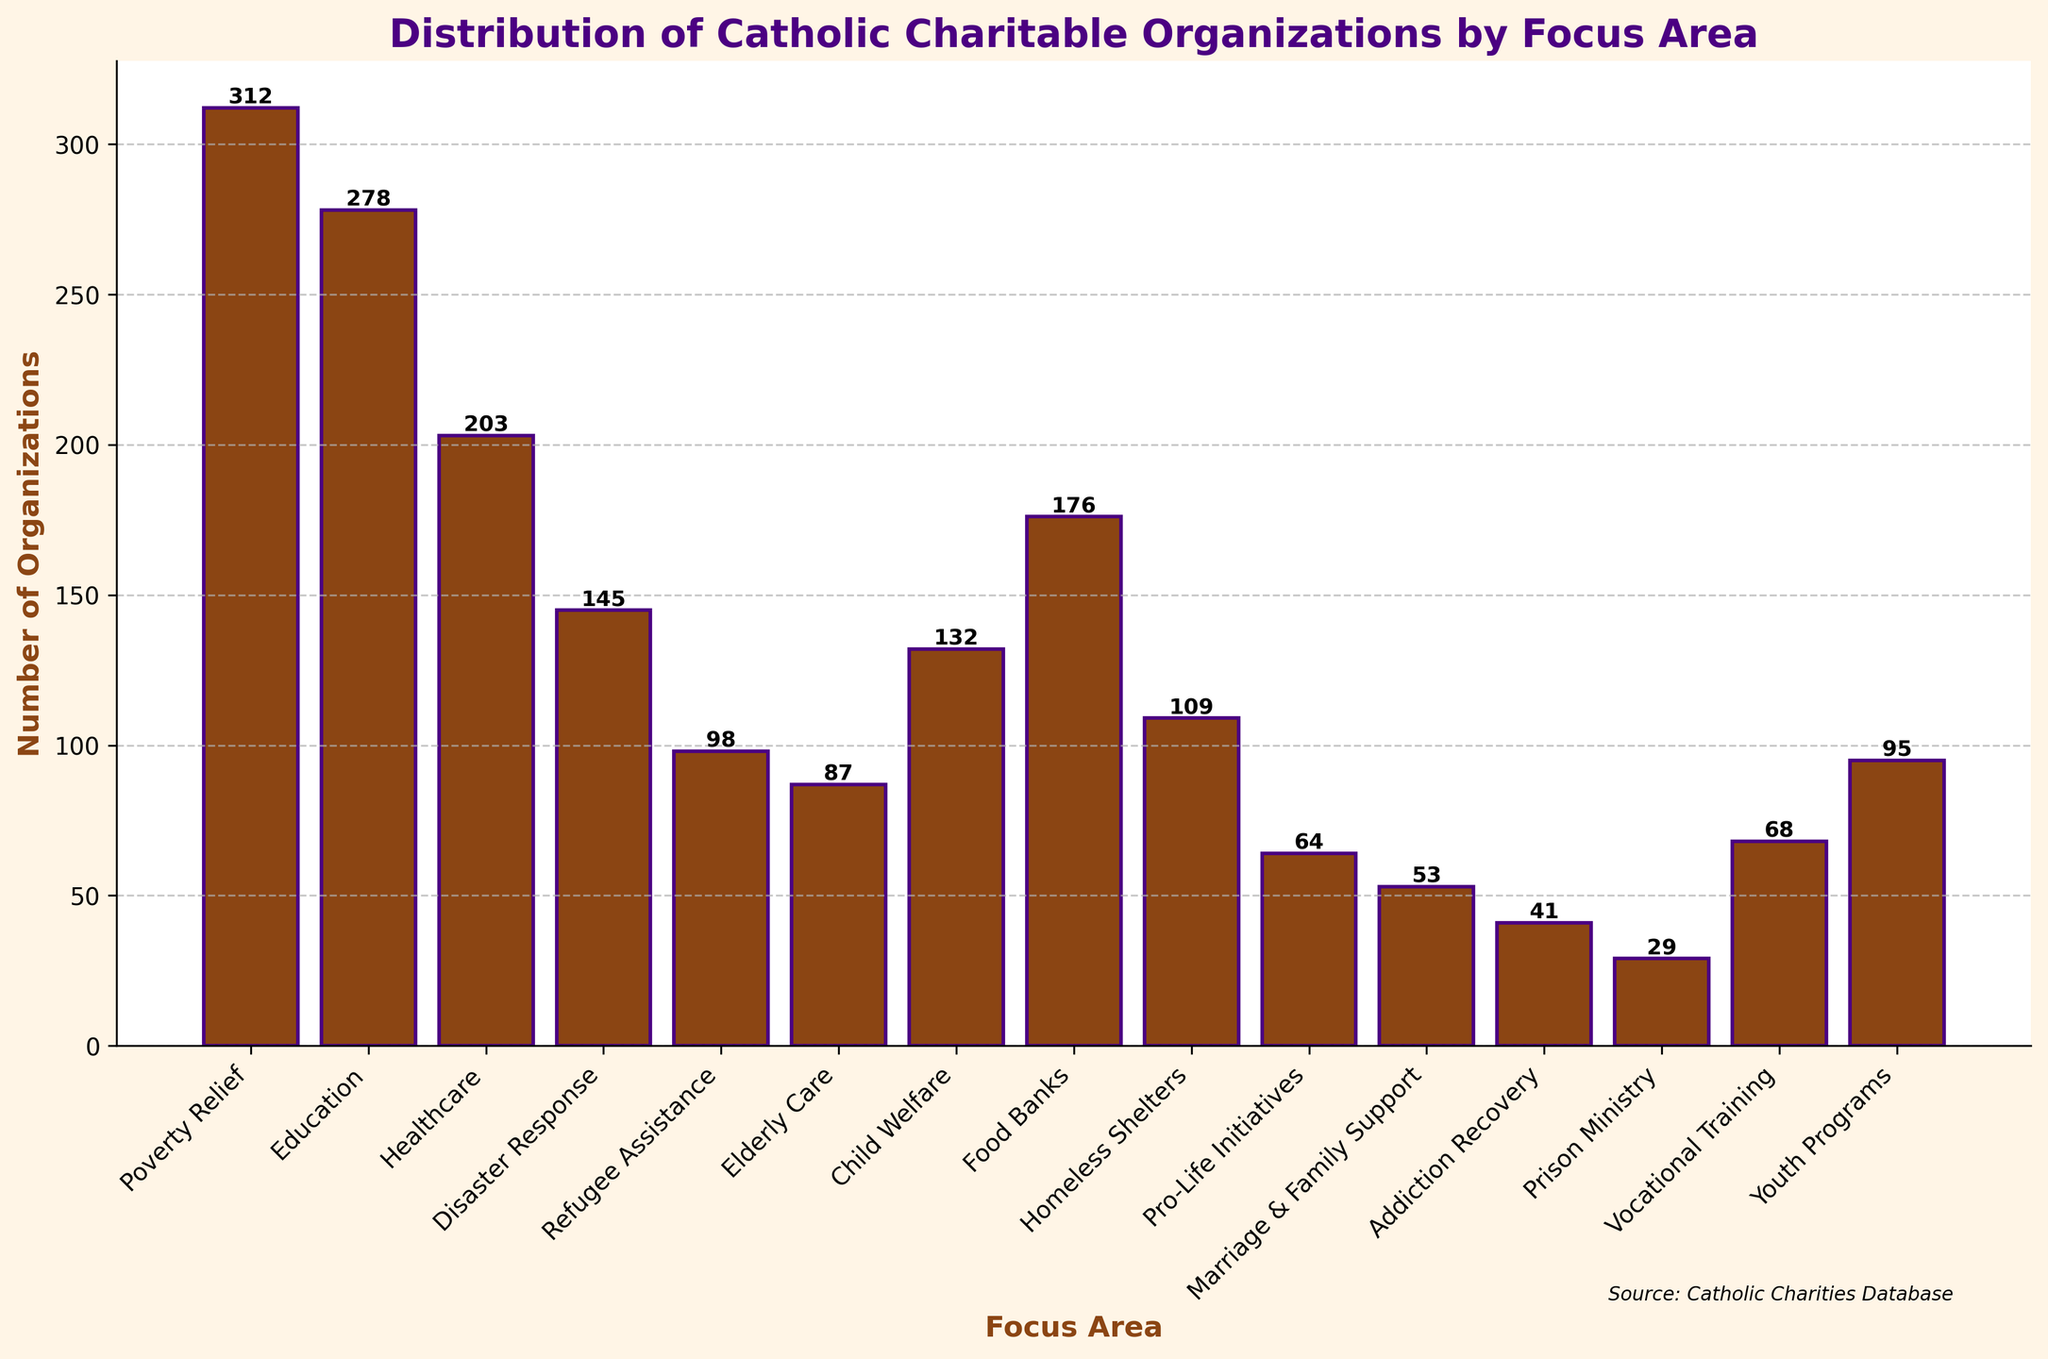Which focus area has the highest number of organizations? By looking at the heights of the bars, the tallest bar represents the focus area with the highest number of organizations. "Poverty Relief" is the tallest bar.
Answer: Poverty Relief Which focus area has the fewest organizations? The shortest bar represents the focus area with the fewest organizations. "Prison Ministry" is the shortest bar.
Answer: Prison Ministry What is the total number of organizations focusing on Healthcare and Education combined? To find the sum, identify the heights of the bars for Healthcare (203) and Education (278) and then add them together. The sum is 203 + 278.
Answer: 481 How many more organizations focus on Poverty Relief compared to Homeless Shelters? To find the difference, identify the heights of the bars for Poverty Relief (312) and Homeless Shelters (109), then subtract the smaller number from the larger. The difference is 312 - 109.
Answer: 203 Which focus area has approximately half the number of organizations as the Poverty Relief focus area? To find this, identify half the number of organizations for Poverty Relief (which is 312 / 2 = 156), then look for a bar with a height close to 156. "Food Banks" with 176 organizations is closest to half of Poverty Relief.
Answer: Food Banks What is the average number of organizations across all focus areas? To calculate the average, sum the number of organizations for all focus areas and then divide by the number of focus areas. The sum is 1839, and there are 15 focus areas, so the average is 1839 / 15.
Answer: 122.6 Is the number of organizations focusing on Pro-Life Initiatives greater than the number focusing on Marriage & Family Support? By comparing the heights of the bars for Pro-Life Initiatives (64) and Marriage & Family Support (53), we see the height of Pro-Life Initiatives is greater.
Answer: Yes Are there more organizations focusing on Child Welfare or Youth Programs? By comparing the heights of the bars for Child Welfare (132) and Youth Programs (95), Child Welfare has a higher bar.
Answer: Child Welfare Which focus area lies between Food Banks and Elderly Care in terms of the number of organizations? By looking at the bar heights, "Homeless Shelters" (109) lies numerically between Food Banks (176) and Elderly Care (87).
Answer: Homeless Shelters What percentage of the total organizations focus on Disaster Response? First, calculate the total number of organizations (1839). Then find the number of organizations for Disaster Response (145). The percentage is (145 / 1839) * 100.
Answer: 7.88% 